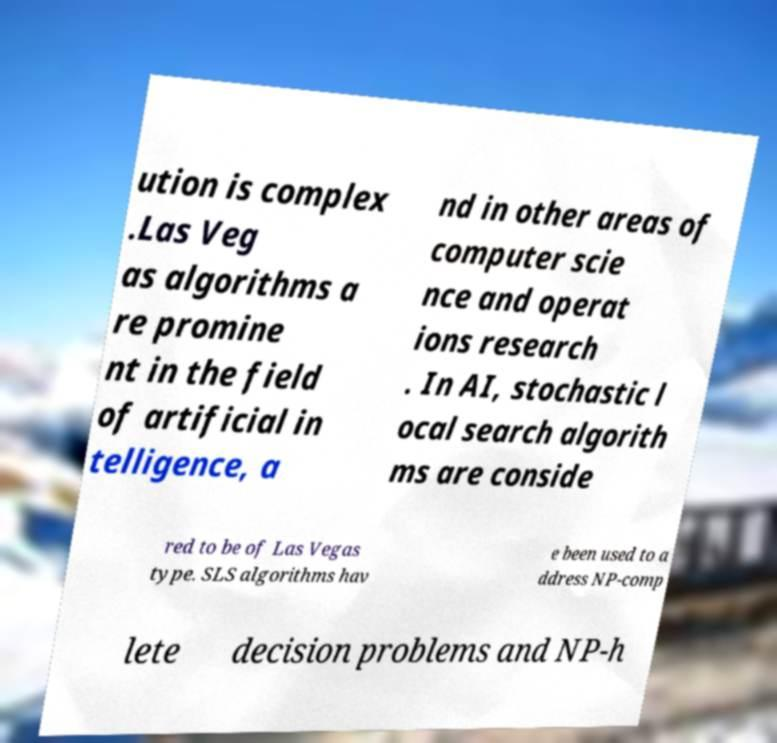Could you assist in decoding the text presented in this image and type it out clearly? ution is complex .Las Veg as algorithms a re promine nt in the field of artificial in telligence, a nd in other areas of computer scie nce and operat ions research . In AI, stochastic l ocal search algorith ms are conside red to be of Las Vegas type. SLS algorithms hav e been used to a ddress NP-comp lete decision problems and NP-h 